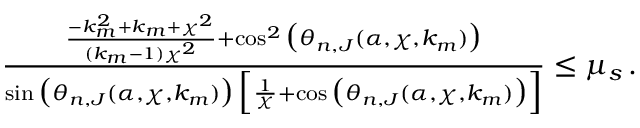<formula> <loc_0><loc_0><loc_500><loc_500>\begin{array} { r } { \frac { \frac { - k _ { m } ^ { 2 } + k _ { m } + \chi ^ { 2 } } { ( k _ { m } - 1 ) \chi ^ { 2 } } + \cos ^ { 2 } \left ( \theta _ { n , J } ( \alpha , \chi , k _ { m } ) \right ) } { \sin \left ( \theta _ { n , J } ( \alpha , \chi , k _ { m } ) \right ) \, \left [ \frac { 1 } { \chi } + \cos \left ( \theta _ { n , J } ( \alpha , \chi , k _ { m } ) \right ) \right ] } \leq \mu _ { s } \, . } \end{array}</formula> 